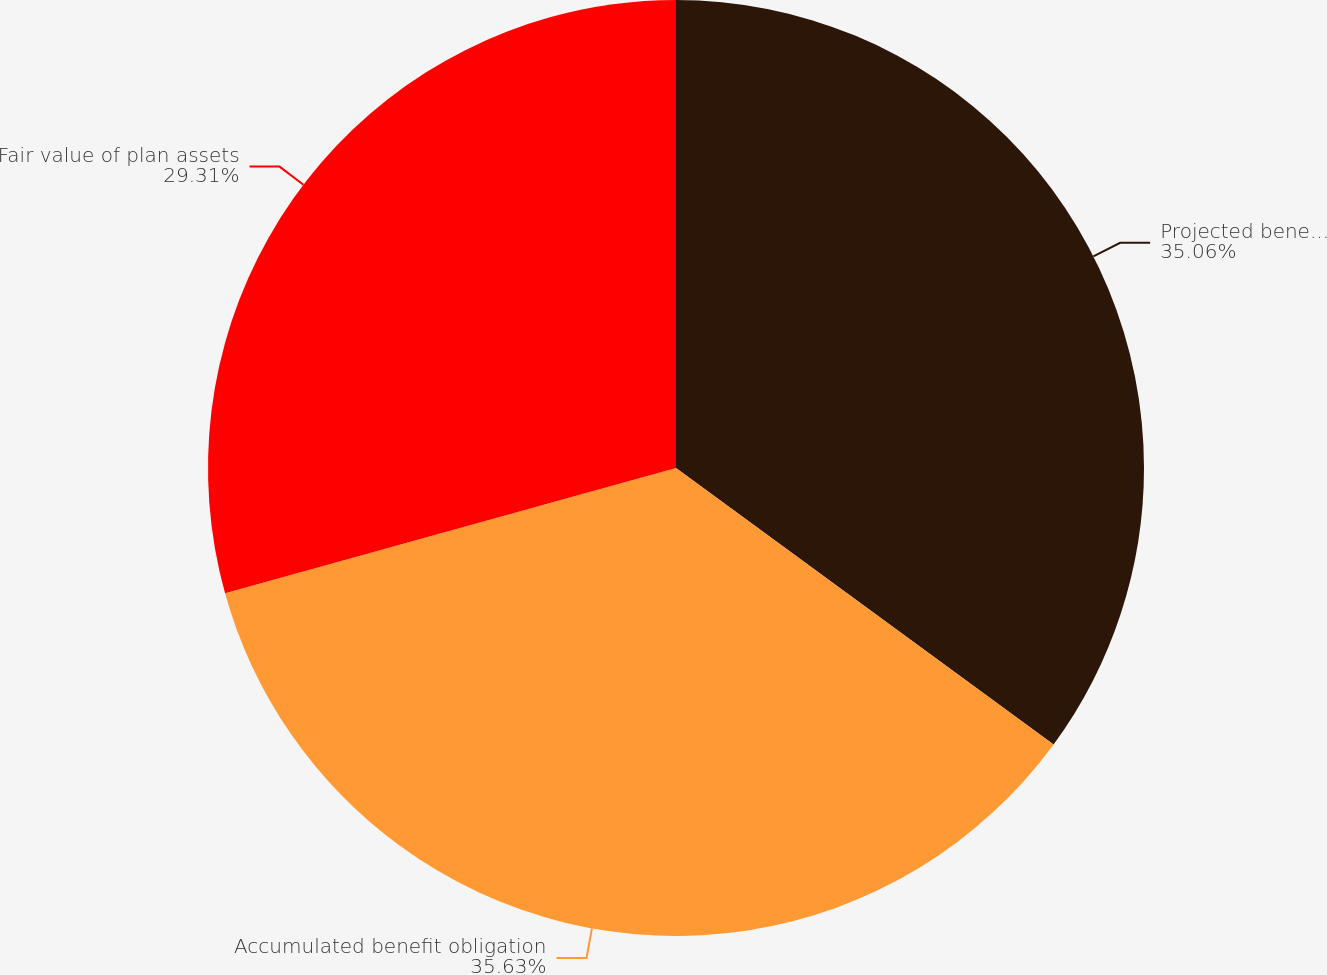<chart> <loc_0><loc_0><loc_500><loc_500><pie_chart><fcel>Projected benefit obligation<fcel>Accumulated benefit obligation<fcel>Fair value of plan assets<nl><fcel>35.06%<fcel>35.63%<fcel>29.31%<nl></chart> 